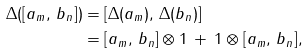<formula> <loc_0><loc_0><loc_500><loc_500>\Delta ( [ a _ { m } , \, b _ { n } ] ) & = [ \Delta ( a _ { m } ) , \, \Delta ( b _ { n } ) ] \\ & = [ a _ { m } , \, b _ { n } ] \otimes 1 \, + \, 1 \otimes [ a _ { m } , \, b _ { n } ] ,</formula> 